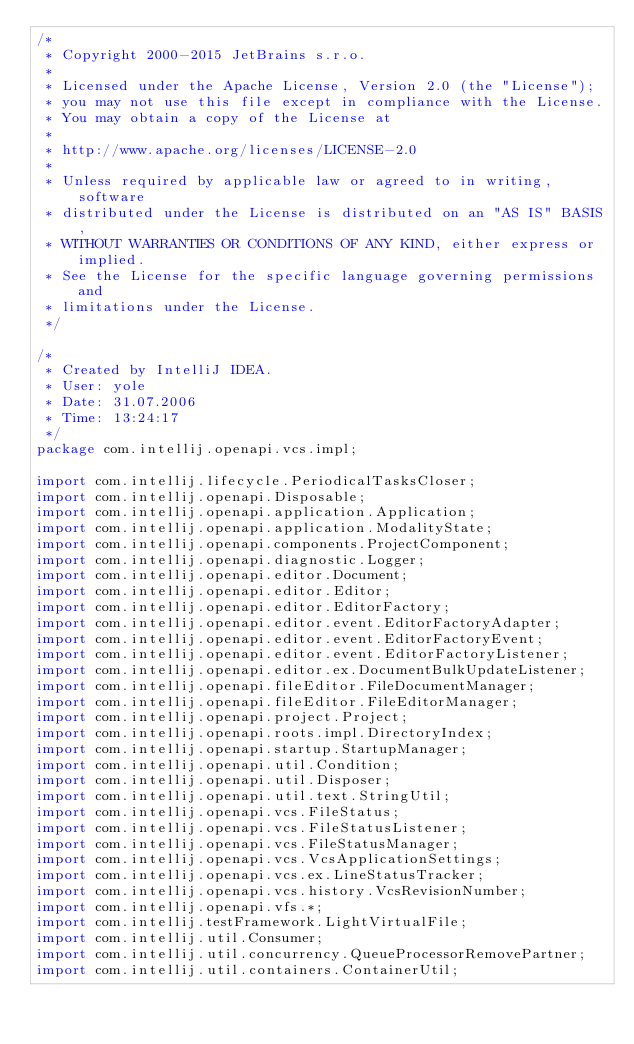<code> <loc_0><loc_0><loc_500><loc_500><_Java_>/*
 * Copyright 2000-2015 JetBrains s.r.o.
 *
 * Licensed under the Apache License, Version 2.0 (the "License");
 * you may not use this file except in compliance with the License.
 * You may obtain a copy of the License at
 *
 * http://www.apache.org/licenses/LICENSE-2.0
 *
 * Unless required by applicable law or agreed to in writing, software
 * distributed under the License is distributed on an "AS IS" BASIS,
 * WITHOUT WARRANTIES OR CONDITIONS OF ANY KIND, either express or implied.
 * See the License for the specific language governing permissions and
 * limitations under the License.
 */

/*
 * Created by IntelliJ IDEA.
 * User: yole
 * Date: 31.07.2006
 * Time: 13:24:17
 */
package com.intellij.openapi.vcs.impl;

import com.intellij.lifecycle.PeriodicalTasksCloser;
import com.intellij.openapi.Disposable;
import com.intellij.openapi.application.Application;
import com.intellij.openapi.application.ModalityState;
import com.intellij.openapi.components.ProjectComponent;
import com.intellij.openapi.diagnostic.Logger;
import com.intellij.openapi.editor.Document;
import com.intellij.openapi.editor.Editor;
import com.intellij.openapi.editor.EditorFactory;
import com.intellij.openapi.editor.event.EditorFactoryAdapter;
import com.intellij.openapi.editor.event.EditorFactoryEvent;
import com.intellij.openapi.editor.event.EditorFactoryListener;
import com.intellij.openapi.editor.ex.DocumentBulkUpdateListener;
import com.intellij.openapi.fileEditor.FileDocumentManager;
import com.intellij.openapi.fileEditor.FileEditorManager;
import com.intellij.openapi.project.Project;
import com.intellij.openapi.roots.impl.DirectoryIndex;
import com.intellij.openapi.startup.StartupManager;
import com.intellij.openapi.util.Condition;
import com.intellij.openapi.util.Disposer;
import com.intellij.openapi.util.text.StringUtil;
import com.intellij.openapi.vcs.FileStatus;
import com.intellij.openapi.vcs.FileStatusListener;
import com.intellij.openapi.vcs.FileStatusManager;
import com.intellij.openapi.vcs.VcsApplicationSettings;
import com.intellij.openapi.vcs.ex.LineStatusTracker;
import com.intellij.openapi.vcs.history.VcsRevisionNumber;
import com.intellij.openapi.vfs.*;
import com.intellij.testFramework.LightVirtualFile;
import com.intellij.util.Consumer;
import com.intellij.util.concurrency.QueueProcessorRemovePartner;
import com.intellij.util.containers.ContainerUtil;</code> 